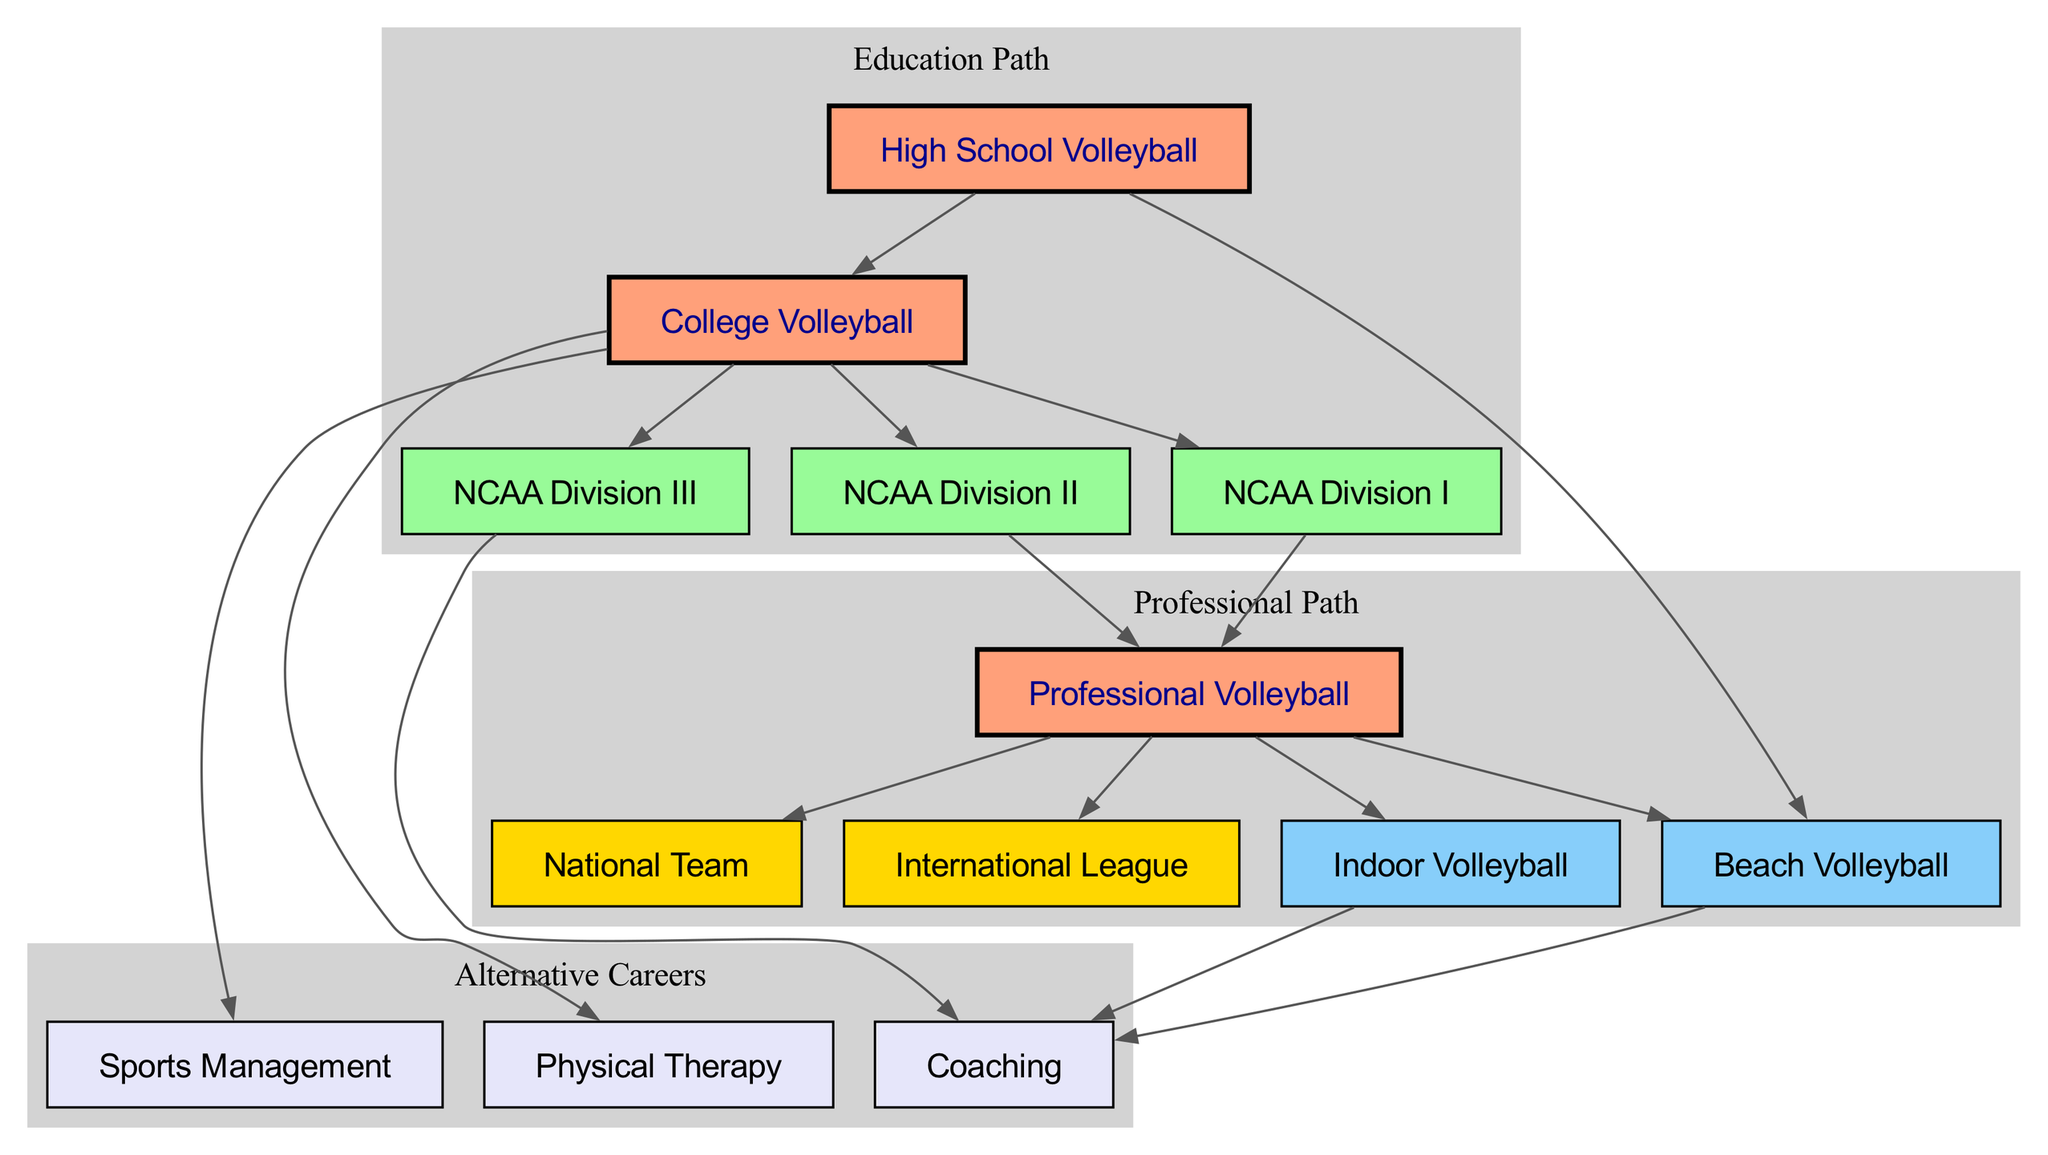What are the three main pathways after high school volleyball? The diagram indicates that there are three pathways that branch off from "High School Volleyball": College Volleyball, Beach Volleyball, and starting with NCAA divisions.
Answer: College Volleyball, Beach Volleyball, NCAA Division I, NCAA Division II, NCAA Division III How many NCAA divisions are shown in the diagram? The diagram includes three NCAA divisions: NCAA Division I, NCAA Division II, and NCAA Division III.
Answer: 3 What opportunities are available after playing professional volleyball? After "Professional Volleyball," the diagram provides four options: International League, National Team, Beach Volleyball, and Indoor Volleyball.
Answer: International League, National Team, Beach Volleyball, Indoor Volleyball Which educational options lead to coaching careers? The coaching careers can be pursued after playing NCAA Division III volleyball, Indoor Volleyball, or Beach Volleyball, as indicated by the directed edges leading from these nodes to Coaching.
Answer: NCAA Division III, Indoor Volleyball, Beach Volleyball What is the immediate next step after NCAA Division I? The immediate next step indicated by the directed edge from NCAA Division I is to Professional Volleyball.
Answer: Professional Volleyball Can you transition from NCAA Division II to the National Team? Yes, there is a pathway from NCAA Division II to Professional Volleyball, which can lead to the National Team based on subsequent pathways shown.
Answer: Yes What career option branches out from College Volleyball besides NCAA divisions? Apart from NCAA divisions, College Volleyball also branches to Sports Management and Physical Therapy as alternate careers.
Answer: Sports Management, Physical Therapy How many edges are there leading from Professional Volleyball? The Professional Volleyball node has four edges leading to International League, National Team, Beach Volleyball, and Indoor Volleyball, representing different career paths.
Answer: 4 